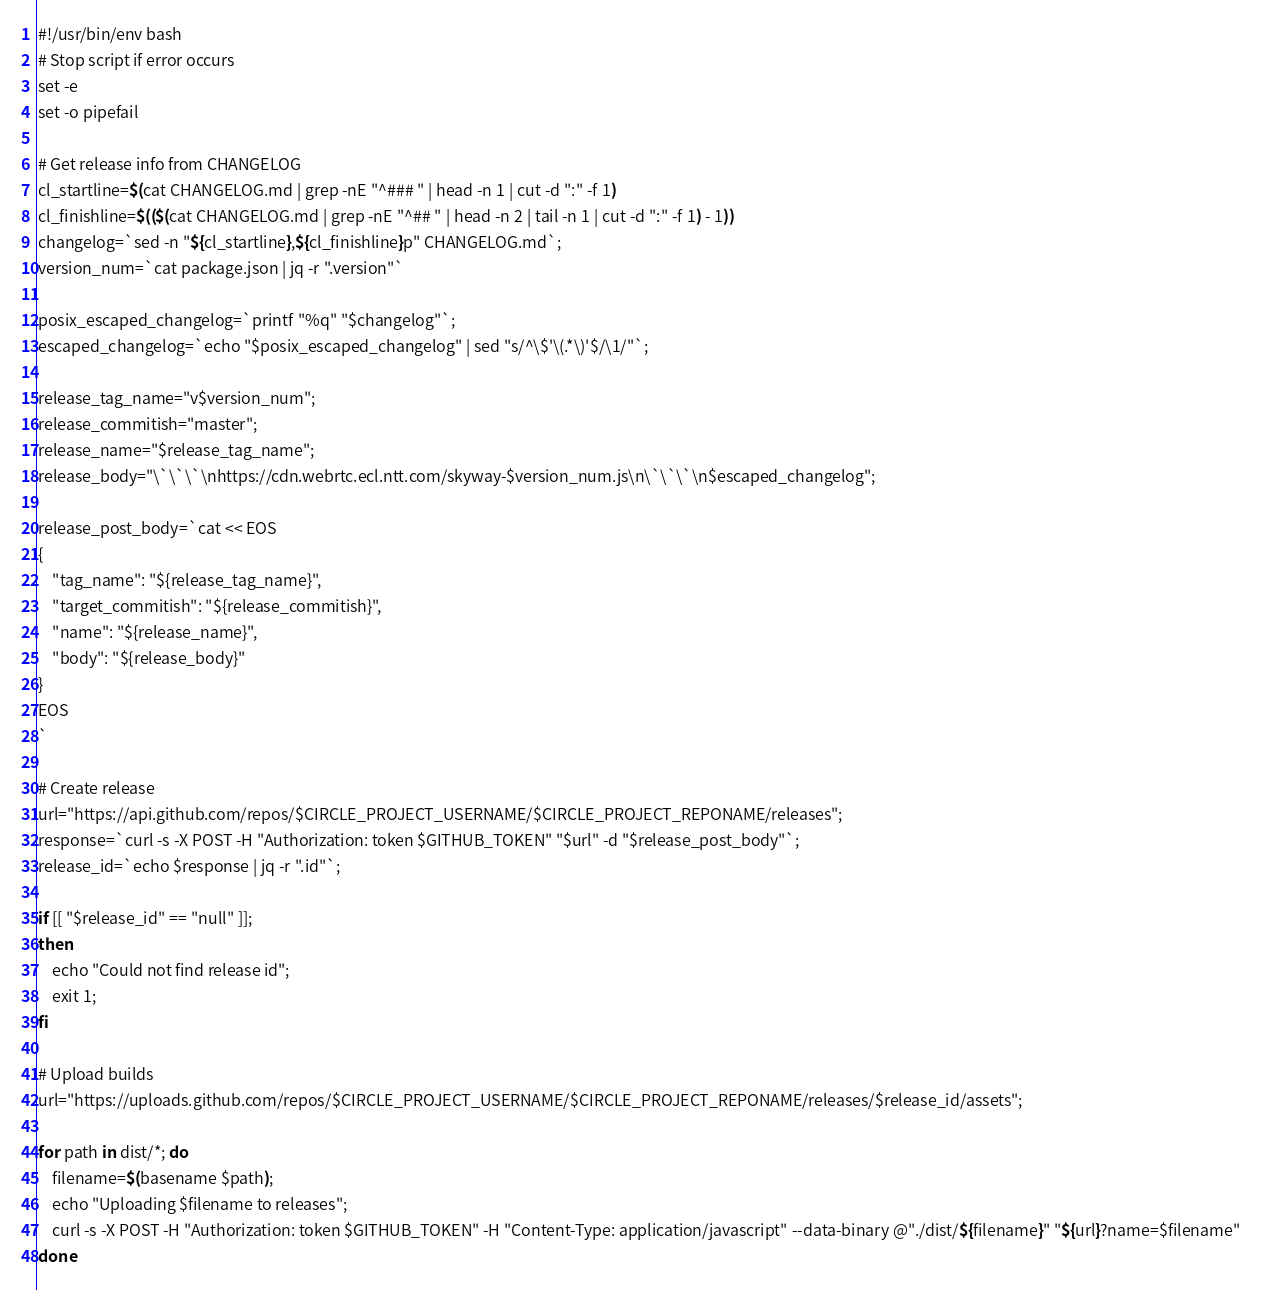<code> <loc_0><loc_0><loc_500><loc_500><_Bash_>#!/usr/bin/env bash
# Stop script if error occurs
set -e
set -o pipefail

# Get release info from CHANGELOG
cl_startline=$(cat CHANGELOG.md | grep -nE "^### " | head -n 1 | cut -d ":" -f 1)
cl_finishline=$(($(cat CHANGELOG.md | grep -nE "^## " | head -n 2 | tail -n 1 | cut -d ":" -f 1) - 1))
changelog=`sed -n "${cl_startline},${cl_finishline}p" CHANGELOG.md`;
version_num=`cat package.json | jq -r ".version"`

posix_escaped_changelog=`printf "%q" "$changelog"`;
escaped_changelog=`echo "$posix_escaped_changelog" | sed "s/^\$'\(.*\)'$/\1/"`;

release_tag_name="v$version_num";
release_commitish="master";
release_name="$release_tag_name";
release_body="\`\`\`\nhttps://cdn.webrtc.ecl.ntt.com/skyway-$version_num.js\n\`\`\`\n$escaped_changelog";

release_post_body=`cat << EOS
{
    "tag_name": "${release_tag_name}",
    "target_commitish": "${release_commitish}",
    "name": "${release_name}",
    "body": "${release_body}"
}
EOS
`

# Create release
url="https://api.github.com/repos/$CIRCLE_PROJECT_USERNAME/$CIRCLE_PROJECT_REPONAME/releases";
response=`curl -s -X POST -H "Authorization: token $GITHUB_TOKEN" "$url" -d "$release_post_body"`;
release_id=`echo $response | jq -r ".id"`;

if [[ "$release_id" == "null" ]];
then
    echo "Could not find release id";
    exit 1;
fi

# Upload builds
url="https://uploads.github.com/repos/$CIRCLE_PROJECT_USERNAME/$CIRCLE_PROJECT_REPONAME/releases/$release_id/assets";

for path in dist/*; do
    filename=$(basename $path);
    echo "Uploading $filename to releases";
    curl -s -X POST -H "Authorization: token $GITHUB_TOKEN" -H "Content-Type: application/javascript" --data-binary @"./dist/${filename}" "${url}?name=$filename"
done
</code> 